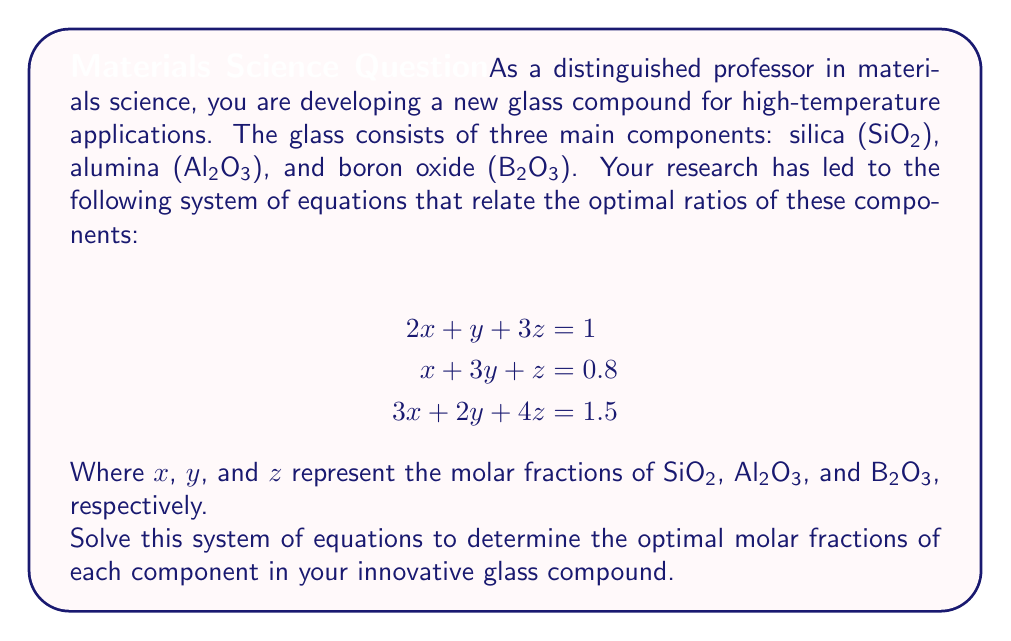Help me with this question. To solve this system of equations, we'll use the Gaussian elimination method:

1) First, let's write our augmented matrix:

   $$\begin{bmatrix}
   2 & 1 & 3 & 1 \\
   1 & 3 & 1 & 0.8 \\
   3 & 2 & 4 & 1.5
   \end{bmatrix}$$

2) We'll use the first equation to eliminate the $x$ term from the second and third equations:

   R2 = R2 - 0.5R1
   R3 = R3 - 1.5R1

   $$\begin{bmatrix}
   2 & 1 & 3 & 1 \\
   0 & 2.5 & -0.5 & 0.3 \\
   0 & 0.5 & -0.5 & 0
   \end{bmatrix}$$

3) Now, we'll use the second equation to eliminate the $y$ term from the third equation:

   R3 = R3 - 0.2R2

   $$\begin{bmatrix}
   2 & 1 & 3 & 1 \\
   0 & 2.5 & -0.5 & 0.3 \\
   0 & 0 & -0.4 & -0.06
   \end{bmatrix}$$

4) We can now solve for $z$ from the third equation:

   $-0.4z = -0.06$
   $z = 0.15$

5) Substituting this value back into the second equation:

   $2.5y - 0.5(0.15) = 0.3$
   $2.5y = 0.375$
   $y = 0.15$

6) Finally, substituting these values into the first equation:

   $2x + 0.15 + 3(0.15) = 1$
   $2x = 0.4$
   $x = 0.2$

Therefore, the optimal molar fractions are:
$x$ (SiO₂) = 0.2
$y$ (Al₂O₃) = 0.15
$z$ (B₂O₃) = 0.15
Answer: The optimal molar fractions for the glass compound are:
SiO₂: 0.2
Al₂O₃: 0.15
B₂O₃: 0.15 